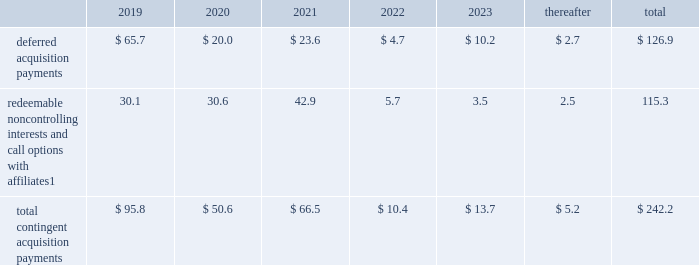Notes to consolidated financial statements 2013 ( continued ) ( amounts in millions , except per share amounts ) guarantees we have guaranteed certain obligations of our subsidiaries relating principally to operating leases and uncommitted lines of credit of certain subsidiaries .
As of december 31 , 2018 and 2017 , the amount of parent company guarantees on lease obligations was $ 824.5 and $ 829.2 , respectively , the amount of parent company guarantees primarily relating to uncommitted lines of credit was $ 349.1 and $ 308.8 , respectively , and the amount of parent company guarantees related to daylight overdrafts , primarily utilized to manage intra-day overdrafts due to timing of transactions under cash pooling arrangements without resulting in incremental borrowings , was $ 207.8 and $ 182.2 , respectively .
In the event of non-payment by the applicable subsidiary of the obligations covered by a guarantee , we would be obligated to pay the amounts covered by that guarantee .
As of december 31 , 2018 , there were no material assets pledged as security for such parent company guarantees .
Contingent acquisition obligations the table details the estimated future contingent acquisition obligations payable in cash as of december 31 .
1 we have entered into certain acquisitions that contain both redeemable noncontrolling interests and call options with similar terms and conditions .
The estimated amounts listed would be paid in the event of exercise at the earliest exercise date .
We have certain redeemable noncontrolling interests that are exercisable at the discretion of the noncontrolling equity owners as of december 31 , 2018 .
These estimated payments of $ 24.9 are included within the total payments expected to be made in 2019 , and will continue to be carried forward into 2020 or beyond until exercised or expired .
Redeemable noncontrolling interests are included in the table at current exercise price payable in cash , not at applicable redemption value , in accordance with the authoritative guidance for classification and measurement of redeemable securities .
The majority of these payments are contingent upon achieving projected operating performance targets and satisfying other conditions specified in the related agreements and are subject to revision in accordance with the terms of the respective agreements .
See note 5 for further information relating to the payment structure of our acquisitions .
Legal matters we are involved in various legal proceedings , and subject to investigations , inspections , audits , inquiries and similar actions by governmental authorities arising in the normal course of business .
The types of allegations that arise in connection with such legal proceedings vary in nature , but can include claims related to contract , employment , tax and intellectual property matters .
We evaluate all cases each reporting period and record liabilities for losses from legal proceedings when we determine that it is probable that the outcome in a legal proceeding will be unfavorable and the amount , or potential range , of loss can be reasonably estimated .
In certain cases , we cannot reasonably estimate the potential loss because , for example , the litigation is in its early stages .
While any outcome related to litigation or such governmental proceedings in which we are involved cannot be predicted with certainty , management believes that the outcome of these matters , individually and in the aggregate , will not have a material adverse effect on our financial condition , results of operations or cash flows .
As previously disclosed , on april 10 , 2015 , a federal judge in brazil authorized the search of the records of an agency 2019s offices in s e3o paulo and brasilia , in connection with an ongoing investigation by brazilian authorities involving payments potentially connected to local government contracts .
The company had previously investigated the matter and taken a number of remedial and disciplinary actions .
The company has been in the process of concluding a settlement related to these matters with government agencies , and that settlement was fully executed in april 2018 .
The company has previously provided for such settlement in its consolidated financial statements. .
What was the change in the future contingent acquisition obligations deferred acquisition payments from 2019 to 2020? 
Computations: (65.7 - 20.0)
Answer: 45.7. Notes to consolidated financial statements 2013 ( continued ) ( amounts in millions , except per share amounts ) guarantees we have guaranteed certain obligations of our subsidiaries relating principally to operating leases and uncommitted lines of credit of certain subsidiaries .
As of december 31 , 2018 and 2017 , the amount of parent company guarantees on lease obligations was $ 824.5 and $ 829.2 , respectively , the amount of parent company guarantees primarily relating to uncommitted lines of credit was $ 349.1 and $ 308.8 , respectively , and the amount of parent company guarantees related to daylight overdrafts , primarily utilized to manage intra-day overdrafts due to timing of transactions under cash pooling arrangements without resulting in incremental borrowings , was $ 207.8 and $ 182.2 , respectively .
In the event of non-payment by the applicable subsidiary of the obligations covered by a guarantee , we would be obligated to pay the amounts covered by that guarantee .
As of december 31 , 2018 , there were no material assets pledged as security for such parent company guarantees .
Contingent acquisition obligations the table details the estimated future contingent acquisition obligations payable in cash as of december 31 .
1 we have entered into certain acquisitions that contain both redeemable noncontrolling interests and call options with similar terms and conditions .
The estimated amounts listed would be paid in the event of exercise at the earliest exercise date .
We have certain redeemable noncontrolling interests that are exercisable at the discretion of the noncontrolling equity owners as of december 31 , 2018 .
These estimated payments of $ 24.9 are included within the total payments expected to be made in 2019 , and will continue to be carried forward into 2020 or beyond until exercised or expired .
Redeemable noncontrolling interests are included in the table at current exercise price payable in cash , not at applicable redemption value , in accordance with the authoritative guidance for classification and measurement of redeemable securities .
The majority of these payments are contingent upon achieving projected operating performance targets and satisfying other conditions specified in the related agreements and are subject to revision in accordance with the terms of the respective agreements .
See note 5 for further information relating to the payment structure of our acquisitions .
Legal matters we are involved in various legal proceedings , and subject to investigations , inspections , audits , inquiries and similar actions by governmental authorities arising in the normal course of business .
The types of allegations that arise in connection with such legal proceedings vary in nature , but can include claims related to contract , employment , tax and intellectual property matters .
We evaluate all cases each reporting period and record liabilities for losses from legal proceedings when we determine that it is probable that the outcome in a legal proceeding will be unfavorable and the amount , or potential range , of loss can be reasonably estimated .
In certain cases , we cannot reasonably estimate the potential loss because , for example , the litigation is in its early stages .
While any outcome related to litigation or such governmental proceedings in which we are involved cannot be predicted with certainty , management believes that the outcome of these matters , individually and in the aggregate , will not have a material adverse effect on our financial condition , results of operations or cash flows .
As previously disclosed , on april 10 , 2015 , a federal judge in brazil authorized the search of the records of an agency 2019s offices in s e3o paulo and brasilia , in connection with an ongoing investigation by brazilian authorities involving payments potentially connected to local government contracts .
The company had previously investigated the matter and taken a number of remedial and disciplinary actions .
The company has been in the process of concluding a settlement related to these matters with government agencies , and that settlement was fully executed in april 2018 .
The company has previously provided for such settlement in its consolidated financial statements. .
What was the percent decrease of redeemable noncontrolling interests and call options with affiliates from 2021 to 2022? 
Computations: (((42.9 - 5.7) / 42.9) * 100)
Answer: 86.71329. 